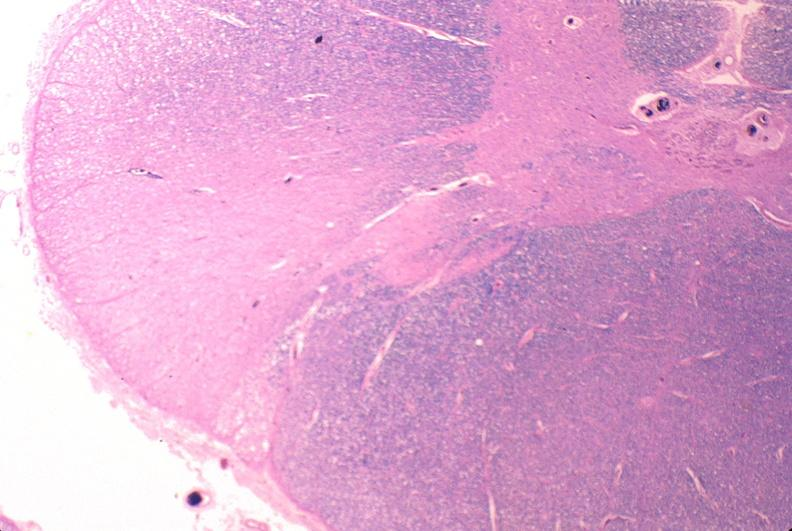what is present?
Answer the question using a single word or phrase. Nervous 